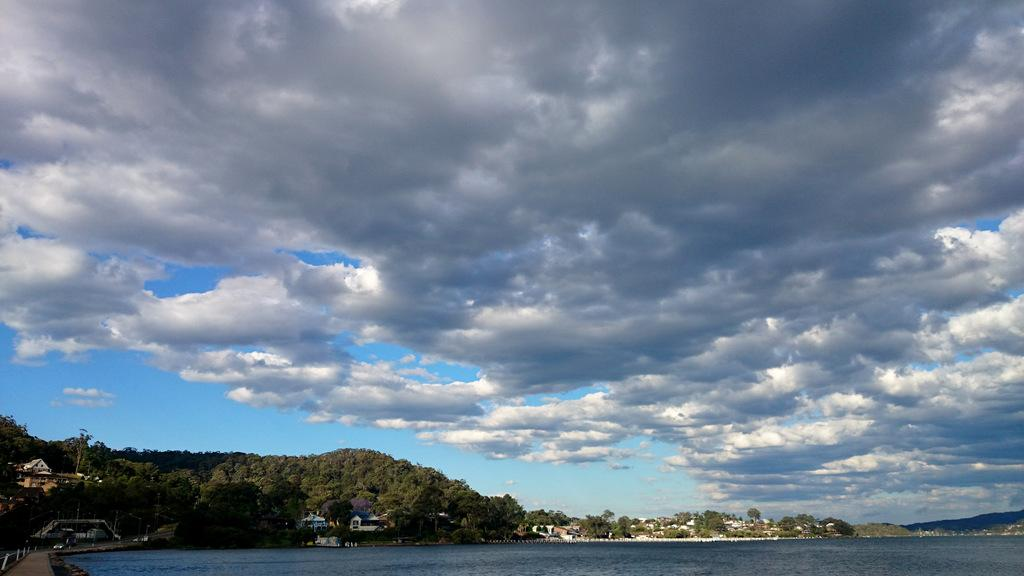What type of natural elements can be seen in the image? There are trees in the image. What type of man-made structures are present in the image? There are buildings in the image. What body of water is visible in the image? There is water visible in the image. How would you describe the sky in the image? The sky is blue and cloudy. Where is the downtown area in the image? There is no specific mention of a downtown area in the image, as it only shows trees, buildings, water, and a blue and cloudy sky. What class is being taught in the image? There is no indication of a class or any educational activity taking place in the image. 